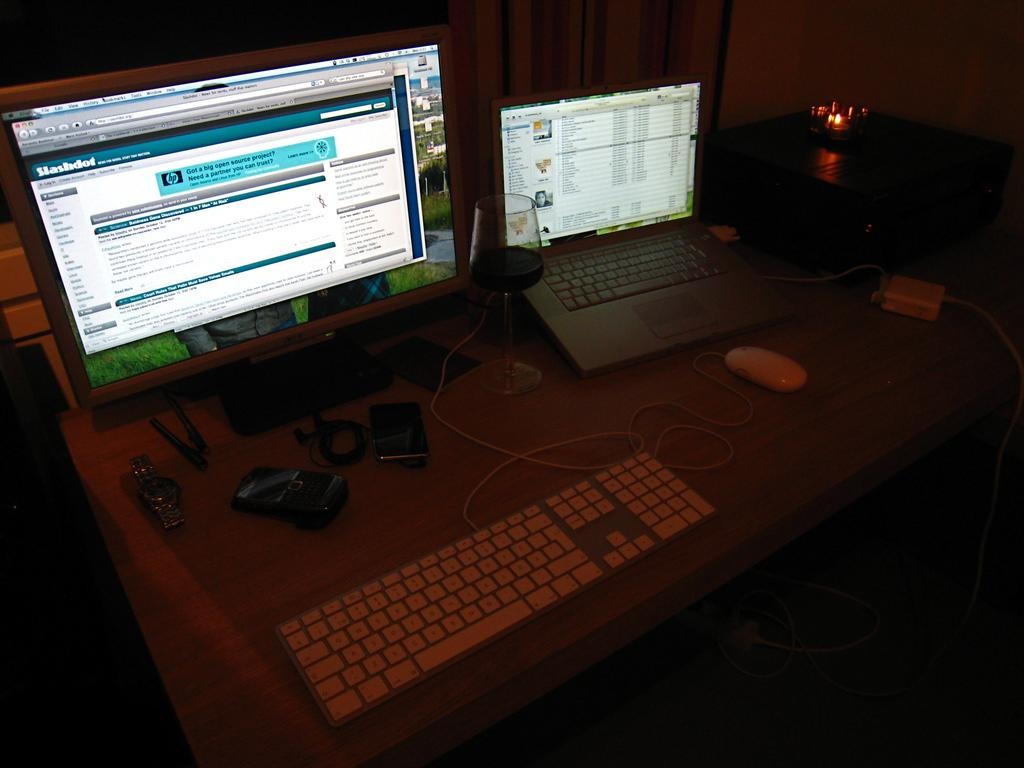What electronic device is visible in the image? There is a laptop in the image. What other electronic device is present in the image? There is a computer in the image. How are the laptop and computer positioned in relation to each other? The laptop and computer are placed beside each other. What type of mass can be seen gathering around the laptop and computer in the image? There is no mass gathering around the laptop and computer in the image. Is there a fight happening between the laptop and computer in the image? No, there is no fight between the laptop and computer in the image. 